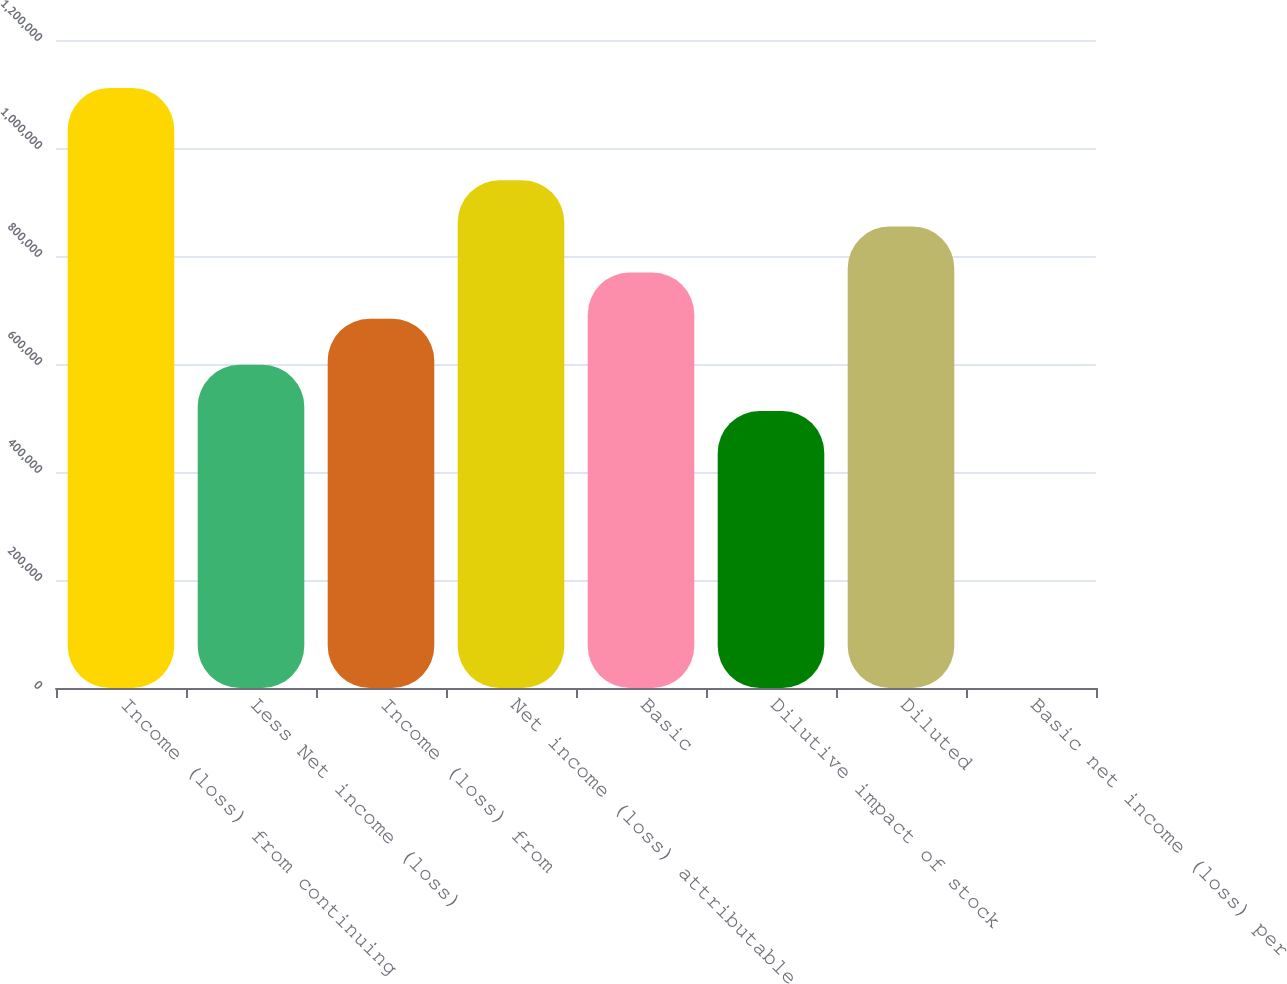Convert chart. <chart><loc_0><loc_0><loc_500><loc_500><bar_chart><fcel>Income (loss) from continuing<fcel>Less Net income (loss)<fcel>Income (loss) from<fcel>Net income (loss) attributable<fcel>Basic<fcel>Dilutive impact of stock<fcel>Diluted<fcel>Basic net income (loss) per<nl><fcel>1.11129e+06<fcel>598385<fcel>683868<fcel>940318<fcel>769352<fcel>512901<fcel>854835<fcel>0.1<nl></chart> 